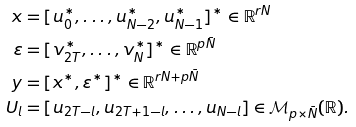<formula> <loc_0><loc_0><loc_500><loc_500>x & = [ u ^ { * } _ { 0 } , \dots , u ^ { * } _ { N - 2 } , u ^ { * } _ { N - 1 } ] ^ { * } \in \mathbb { R } ^ { r N } \\ \varepsilon & = [ v _ { 2 T } ^ { * } , \dots , v ^ { * } _ { N } ] ^ { * } \in \mathbb { R } ^ { p \bar { N } } \\ y & = [ x ^ { * } , \varepsilon ^ { * } ] ^ { * } \in \mathbb { R } ^ { r N + p \bar { N } } \\ U _ { l } & = [ u _ { 2 T - l } , u _ { 2 T + 1 - l } , \dots , u _ { N - l } ] \in \mathcal { M } _ { p \times \bar { N } } ( \mathbb { R } ) .</formula> 